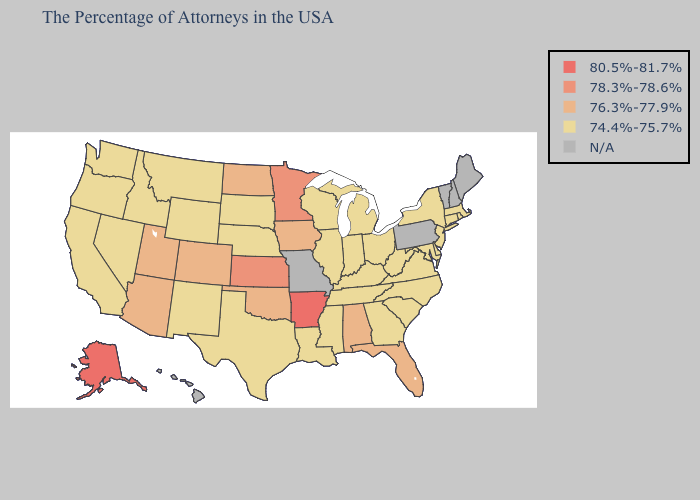Name the states that have a value in the range 74.4%-75.7%?
Give a very brief answer. Massachusetts, Rhode Island, Connecticut, New York, New Jersey, Delaware, Maryland, Virginia, North Carolina, South Carolina, West Virginia, Ohio, Georgia, Michigan, Kentucky, Indiana, Tennessee, Wisconsin, Illinois, Mississippi, Louisiana, Nebraska, Texas, South Dakota, Wyoming, New Mexico, Montana, Idaho, Nevada, California, Washington, Oregon. Name the states that have a value in the range 74.4%-75.7%?
Short answer required. Massachusetts, Rhode Island, Connecticut, New York, New Jersey, Delaware, Maryland, Virginia, North Carolina, South Carolina, West Virginia, Ohio, Georgia, Michigan, Kentucky, Indiana, Tennessee, Wisconsin, Illinois, Mississippi, Louisiana, Nebraska, Texas, South Dakota, Wyoming, New Mexico, Montana, Idaho, Nevada, California, Washington, Oregon. Does North Dakota have the lowest value in the MidWest?
Keep it brief. No. Does Wyoming have the highest value in the USA?
Quick response, please. No. What is the value of Nevada?
Be succinct. 74.4%-75.7%. Is the legend a continuous bar?
Give a very brief answer. No. What is the value of North Carolina?
Keep it brief. 74.4%-75.7%. How many symbols are there in the legend?
Be succinct. 5. Name the states that have a value in the range 78.3%-78.6%?
Keep it brief. Minnesota, Kansas. What is the value of Colorado?
Be succinct. 76.3%-77.9%. What is the value of Washington?
Quick response, please. 74.4%-75.7%. What is the highest value in the South ?
Give a very brief answer. 80.5%-81.7%. 